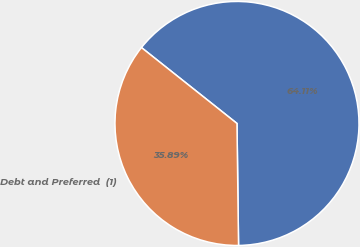Convert chart. <chart><loc_0><loc_0><loc_500><loc_500><pie_chart><ecel><fcel>Debt and Preferred  (1)<nl><fcel>64.11%<fcel>35.89%<nl></chart> 